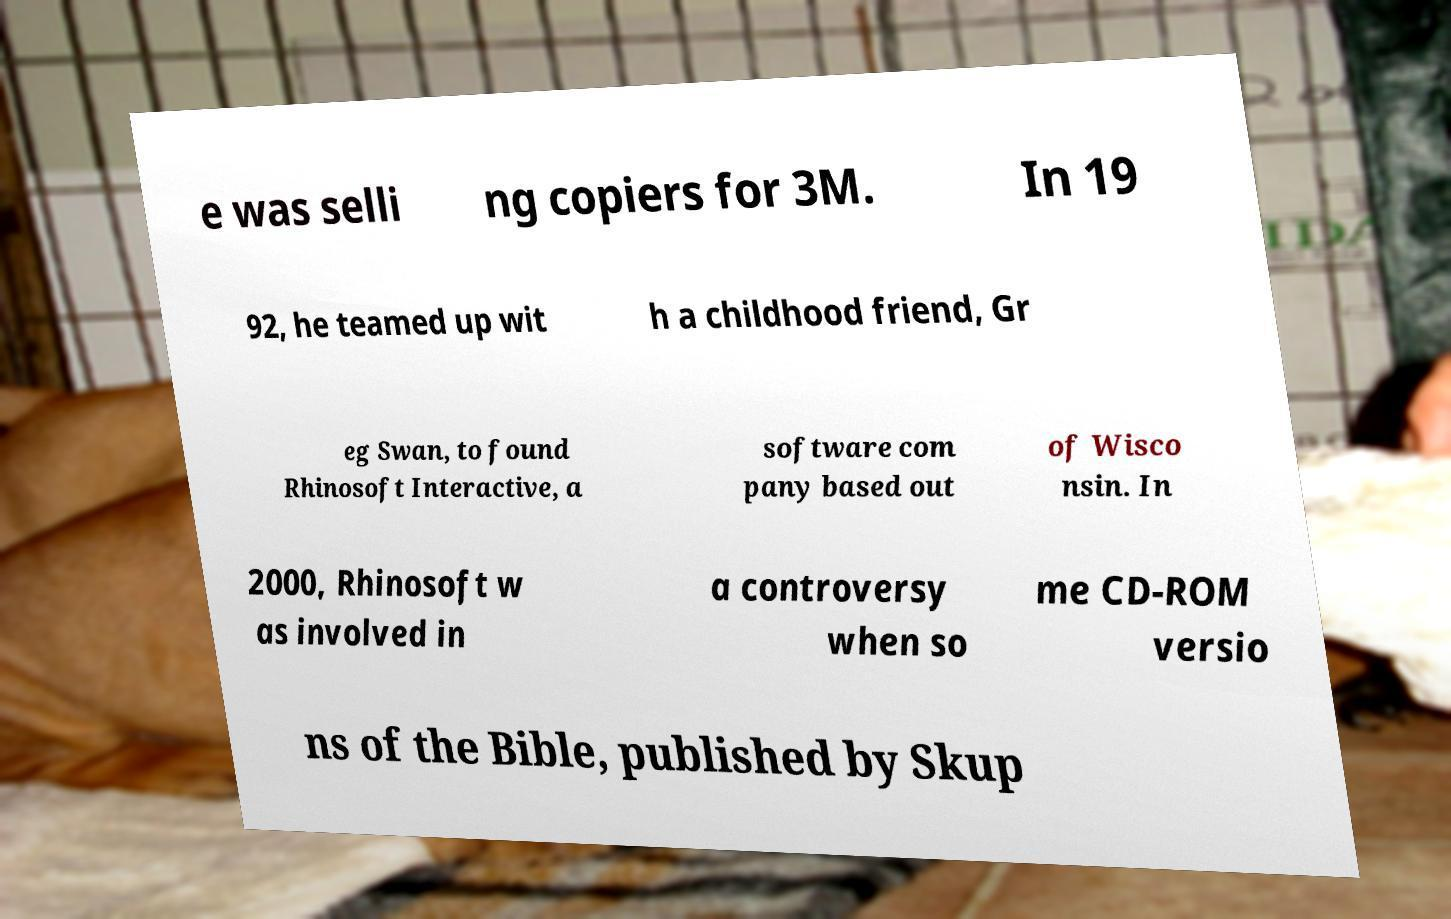Please read and relay the text visible in this image. What does it say? e was selli ng copiers for 3M. In 19 92, he teamed up wit h a childhood friend, Gr eg Swan, to found Rhinosoft Interactive, a software com pany based out of Wisco nsin. In 2000, Rhinosoft w as involved in a controversy when so me CD-ROM versio ns of the Bible, published by Skup 